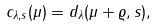Convert formula to latex. <formula><loc_0><loc_0><loc_500><loc_500>c _ { \lambda , s } ( \mu ) = d _ { \lambda } ( \mu + \varrho , s ) ,</formula> 